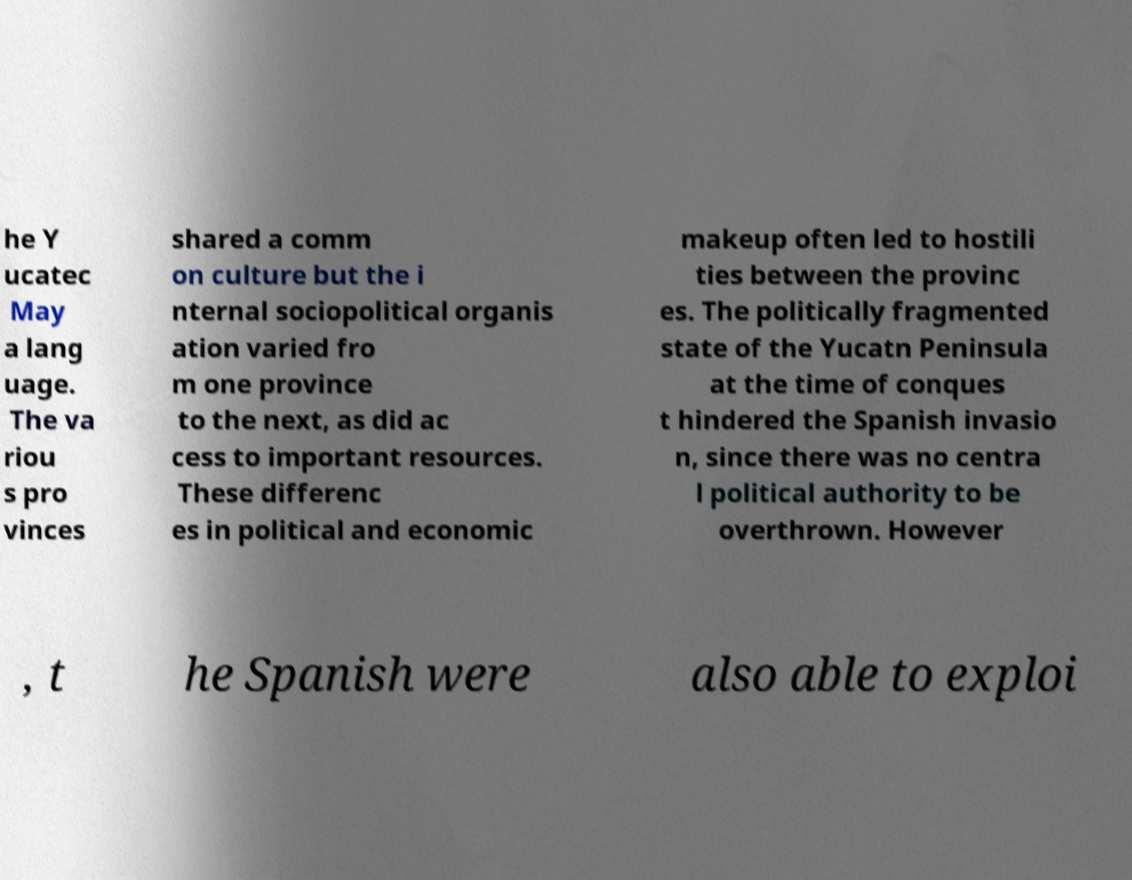What messages or text are displayed in this image? I need them in a readable, typed format. he Y ucatec May a lang uage. The va riou s pro vinces shared a comm on culture but the i nternal sociopolitical organis ation varied fro m one province to the next, as did ac cess to important resources. These differenc es in political and economic makeup often led to hostili ties between the provinc es. The politically fragmented state of the Yucatn Peninsula at the time of conques t hindered the Spanish invasio n, since there was no centra l political authority to be overthrown. However , t he Spanish were also able to exploi 